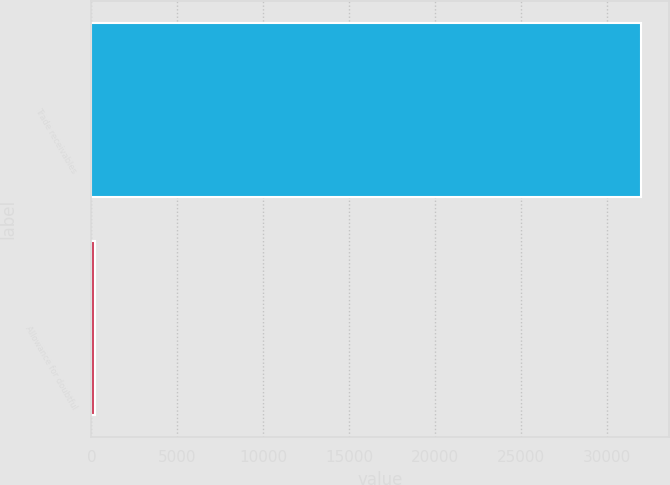<chart> <loc_0><loc_0><loc_500><loc_500><bar_chart><fcel>Trade receivables<fcel>Allowance for doubtful<nl><fcel>32005<fcel>177<nl></chart> 